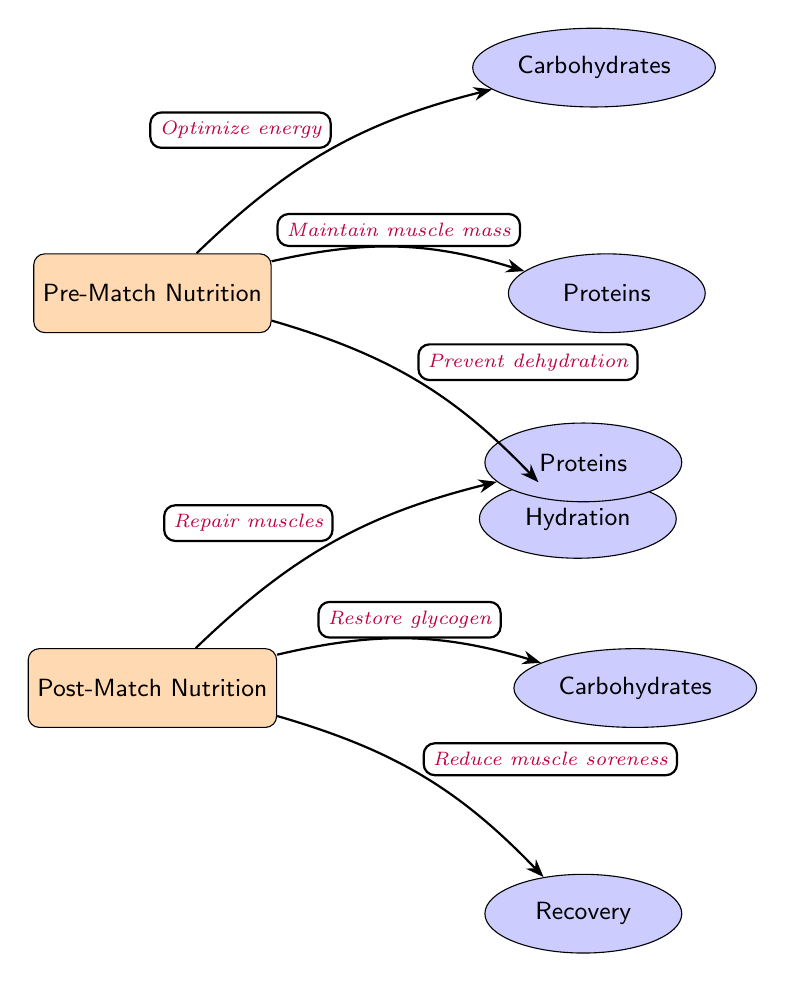What are the three components of pre-match nutrition? The diagram shows three nodes associated with pre-match nutrition: Carbohydrates, Proteins, and Hydration, indicating the essential nutrients that competitive wrestlers should focus on before a match.
Answer: Carbohydrates, Proteins, Hydration How many edges connect to the post-match nutrition? The diagram visually represents three edges stemming from the Post-Match Nutrition node, each leading to a specific aspect of post-match recovery: Proteins, Carbohydrates, and Recovery.
Answer: 3 What is the purpose of carbohydrates in pre-match nutrition? The edge connecting Pre-Match Nutrition to Carbohydrates is labeled "Optimize energy," summarizing the importance of carbohydrates in providing the necessary energy for wrestlers prior to competition.
Answer: Optimize energy Which nutrient is associated with muscle repair in the post-match nutrition? By examining the Post-Match Nutrition node and its edges, we see that the edge leading to Proteins is labeled "Repair muscles," indicating that proteins are critical for muscle recovery after matches.
Answer: Proteins What nutrient is crucial for hydration before a match? The Pre-Match Nutrition section shows an edge leading to the Hydration node, indicating that maintaining hydration is crucial for wrestlers prior to competition.
Answer: Hydration What is the primary goal of post-match carbohydrates? The edge connecting Post-Match Nutrition to Carbohydrates is labeled "Restore glycogen," highlighting that the key purpose of carbohydrates after a match is to replenish glycogen stores in the body.
Answer: Restore glycogen What connection exists between pre-match protein and muscle mass? The arrow from Pre-Match Nutrition to Proteins is labeled "Maintain muscle mass," which describes the relationship, showing that adequate protein intake is essential for preserving muscle mass before competition.
Answer: Maintain muscle mass What is one outcome of post-match recovery nutrition? The diagram states that the edge going to the Recovery node is labeled "Reduce muscle soreness," indicating a specific benefit that is achieved through proper recovery nutrition following a match.
Answer: Reduce muscle soreness 